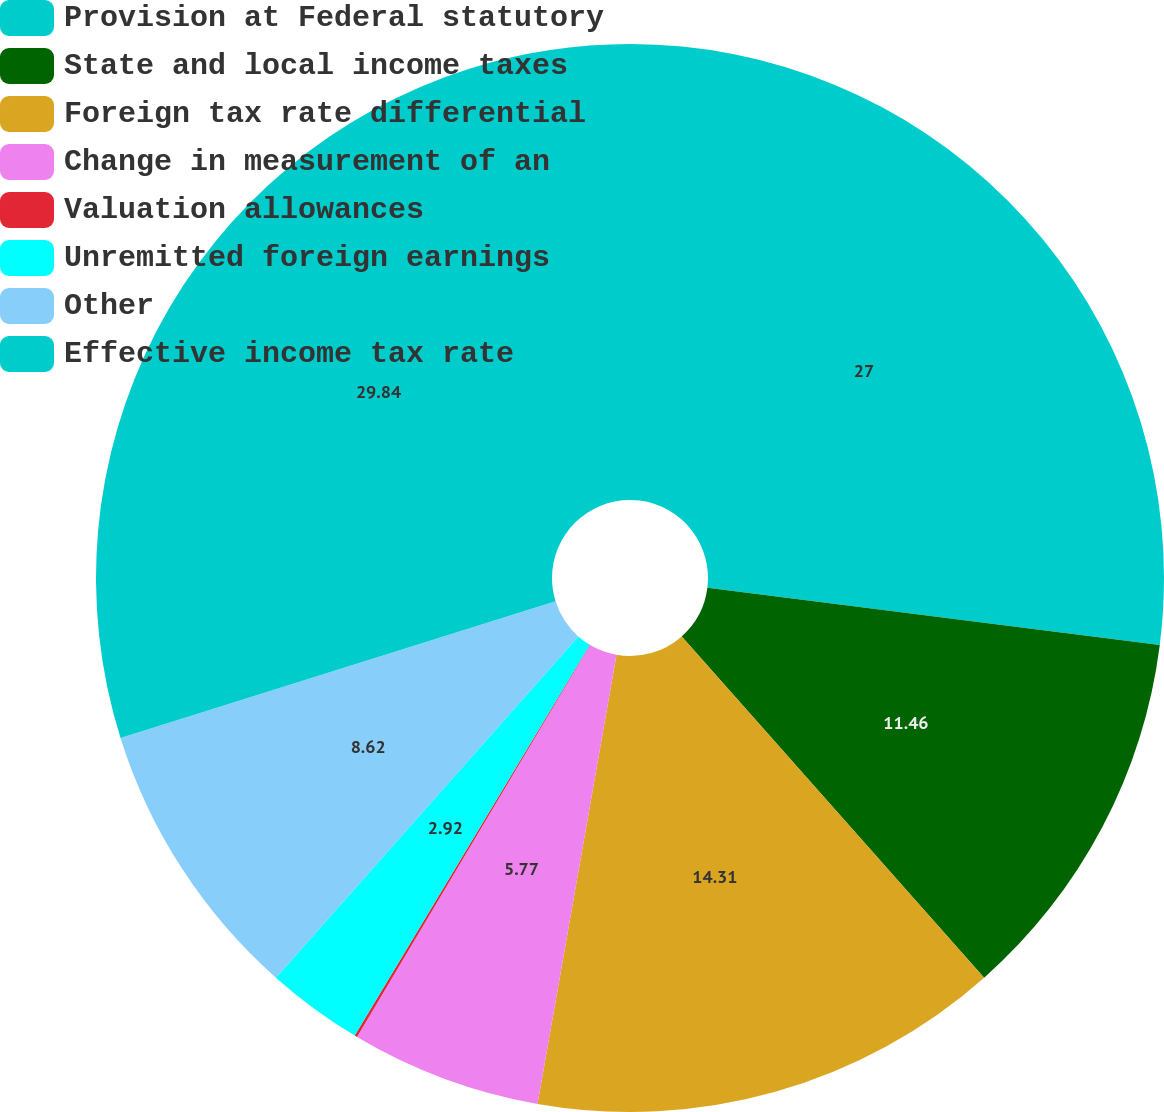Convert chart. <chart><loc_0><loc_0><loc_500><loc_500><pie_chart><fcel>Provision at Federal statutory<fcel>State and local income taxes<fcel>Foreign tax rate differential<fcel>Change in measurement of an<fcel>Valuation allowances<fcel>Unremitted foreign earnings<fcel>Other<fcel>Effective income tax rate<nl><fcel>27.0%<fcel>11.46%<fcel>14.31%<fcel>5.77%<fcel>0.08%<fcel>2.92%<fcel>8.62%<fcel>29.84%<nl></chart> 